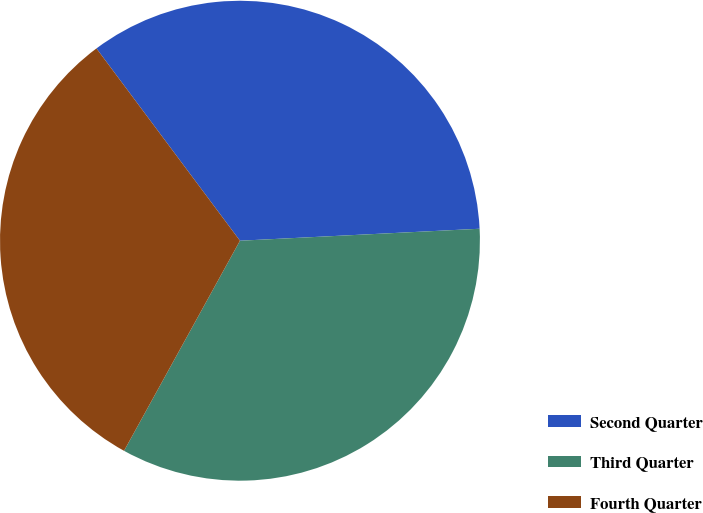<chart> <loc_0><loc_0><loc_500><loc_500><pie_chart><fcel>Second Quarter<fcel>Third Quarter<fcel>Fourth Quarter<nl><fcel>34.41%<fcel>33.82%<fcel>31.77%<nl></chart> 